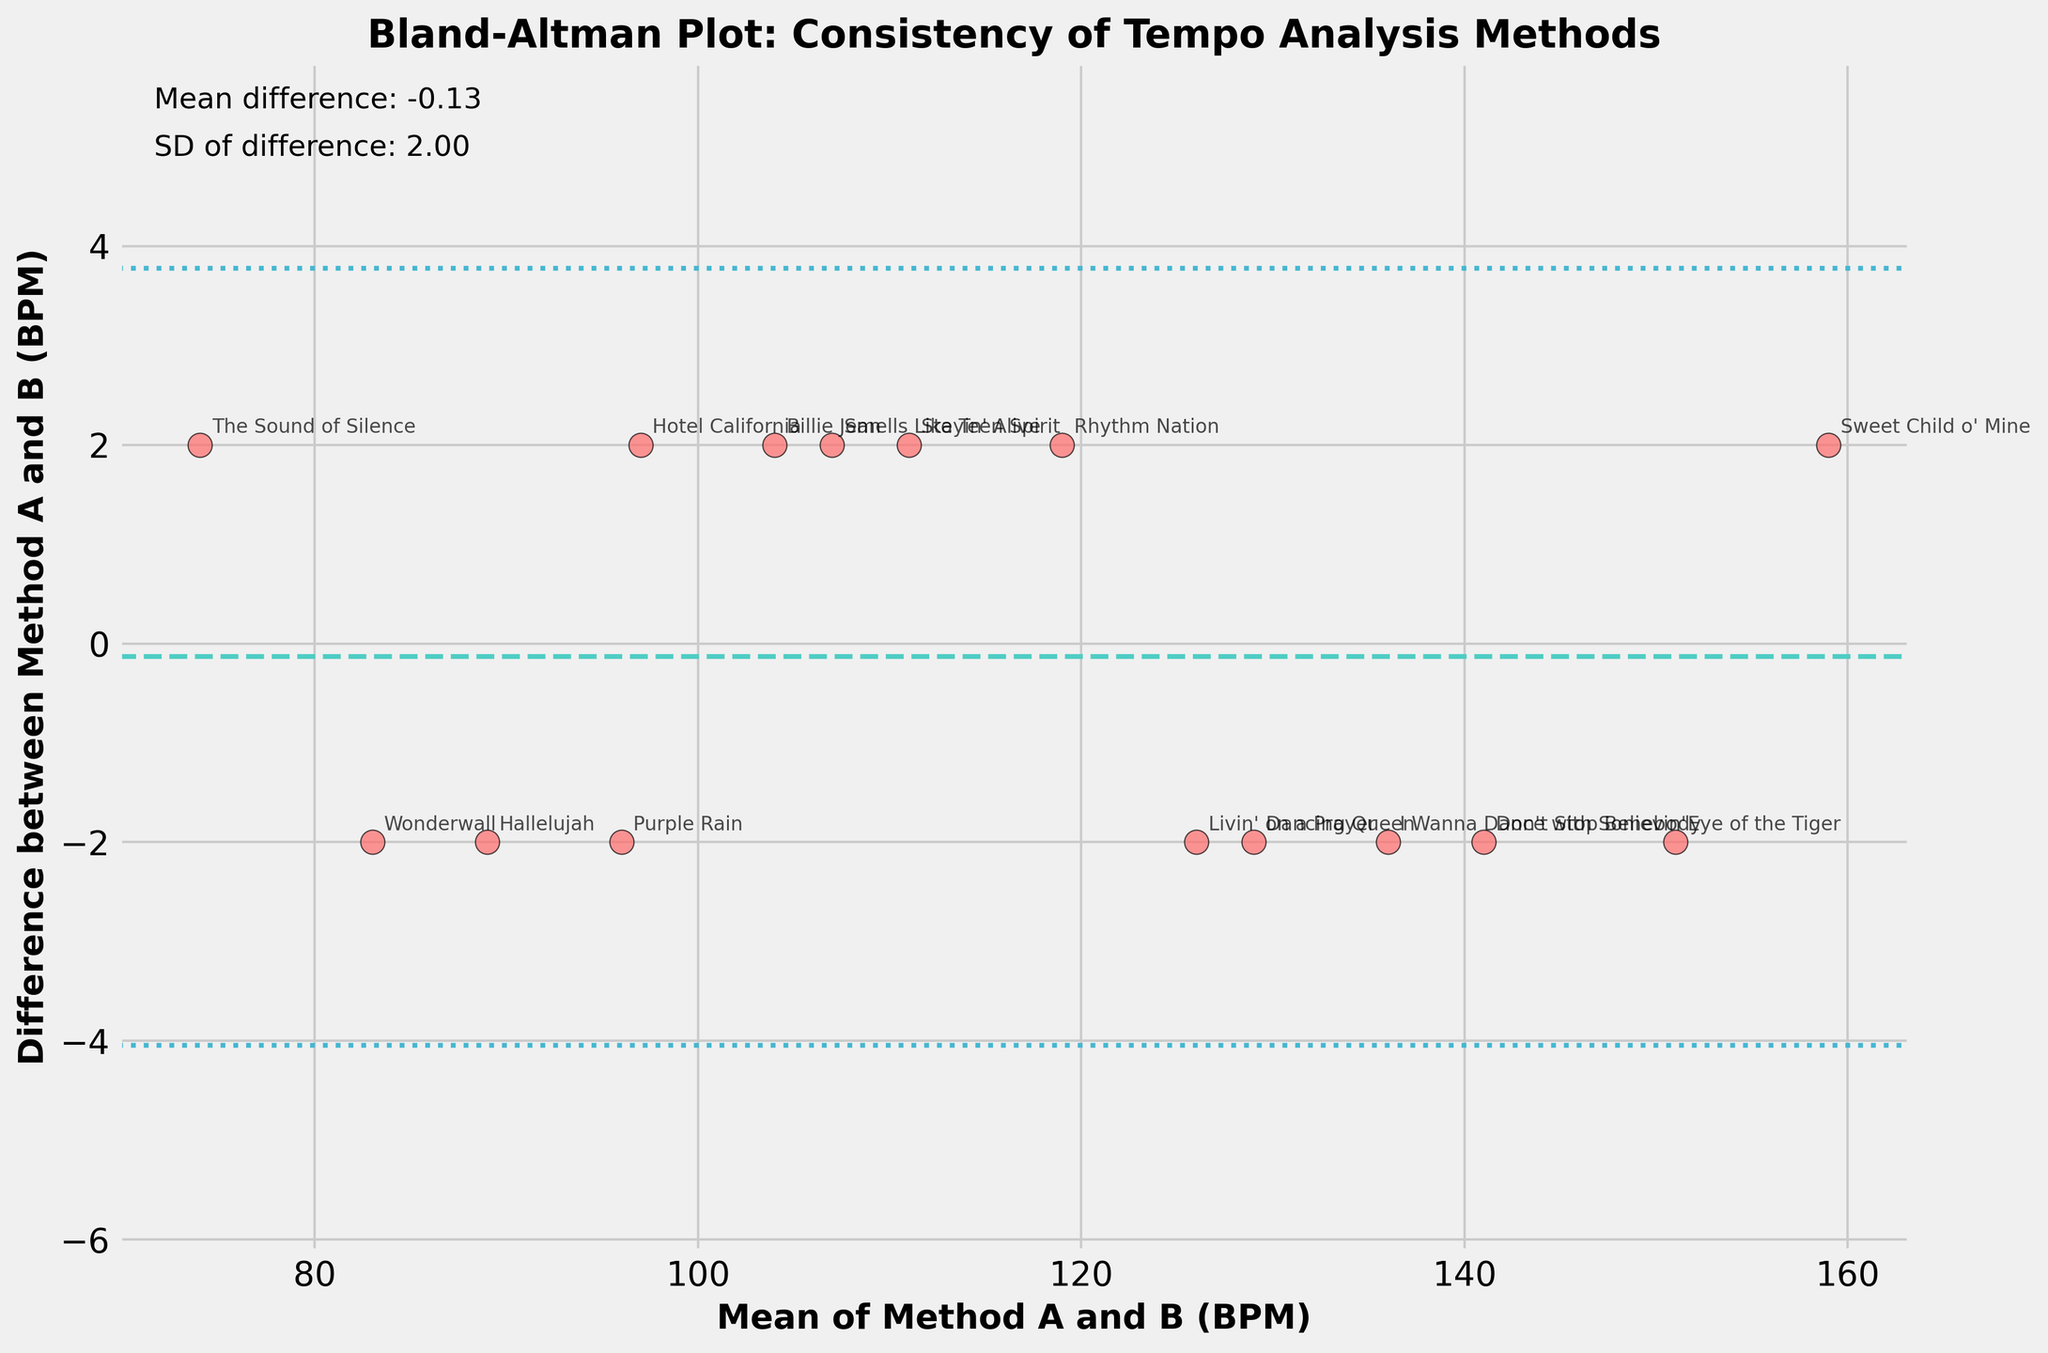What is the title of the figure? The title appears at the top of the plot, which states the main subject of the visual representation.
Answer: Bland-Altman Plot: Consistency of Tempo Analysis Methods How many songs are represented in the figure? The number of data points (song titles) shown in the scatter plot represents the number of songs, and each song has an annotated name next to it.
Answer: 15 What is the mean difference between Method A and Method B? The mean difference is indicated by a horizontal line labeled on the plot and is also mentioned in the text within the figure.
Answer: 0.53 What is the standard deviation of the differences? The standard deviation can be identified by finding the text on the plot that mentions it directly.
Answer: 2.19 What are the colors used for the scatter points and horizontal lines? By observing the scatter points and horizontal lines in the Bland-Altman plot, one can note the colors used.
Answer: Scatter points: red, Horizontal lines: green (mean), blue (SD) What is the range of BPM differences shown on the y-axis? The y-axis denotes the differences between BPMs of Method A and Method B, and the range can be deduced from the observed y-axis limits.
Answer: Approximately -6 to 6 Which song has the highest positive difference between Method A and Method B? Look for the point on the scatter plot with the highest positive value on the y-axis and identify the song annotated at that point.
Answer: Purple Rain Which song has the lowest average BPM between Method A and Method B? Identify the point with the lowest value on the x-axis, which represents the mean BPM of both methods, and read the song title annotation.
Answer: The Sound of Silence What are the upper and lower limits of agreement for the differences? The upper and lower limits are shown by dotted horizontal lines in the plot; their values are derived from the mean difference plus and minus 1.96 times the standard deviation.
Answer: Upper limit: 4.83, Lower limit: -3.77 By how much does the BPM of 'I Wanna Dance with Somebody' differ between Method A and Method B? Locate the data point for 'I Wanna Dance with Somebody' on the plot and observe its vertical position.
Answer: 2 BPM 